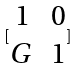<formula> <loc_0><loc_0><loc_500><loc_500>[ \begin{matrix} 1 & 0 \\ G & 1 \end{matrix} ]</formula> 